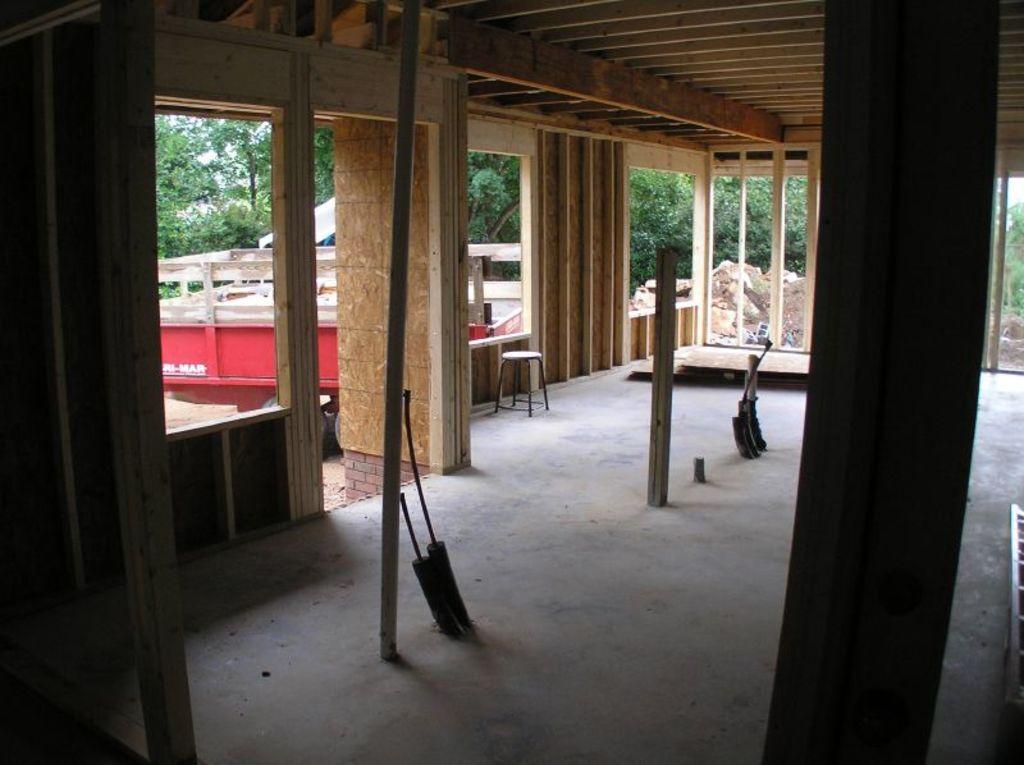Describe this image in one or two sentences. In this image there is a room, pillars, few objects in the room, trees, a vehicle, sand, stones and a tent. 